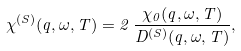<formula> <loc_0><loc_0><loc_500><loc_500>\chi ^ { ( S ) } ( q , \omega , T ) = 2 \, { \frac { \chi _ { 0 } ( q , \omega , T ) } { D ^ { ( S ) } ( q , \omega , T ) } } ,</formula> 